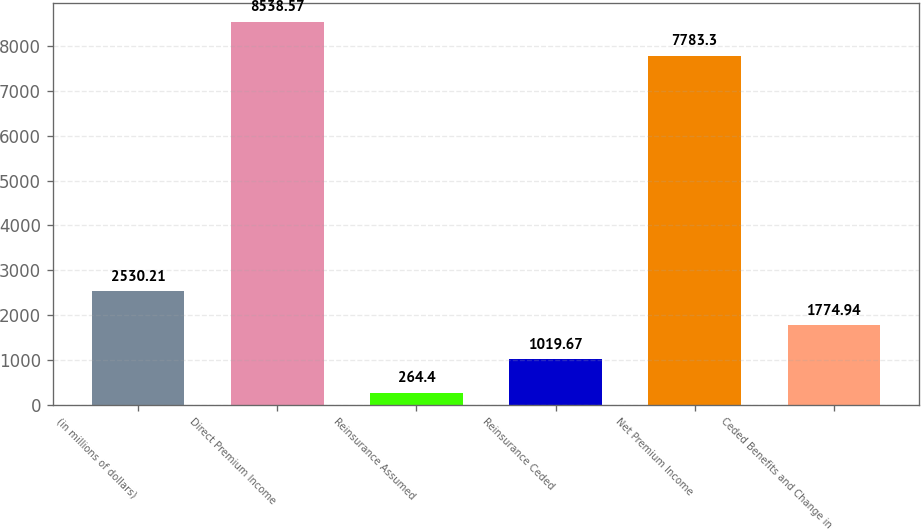<chart> <loc_0><loc_0><loc_500><loc_500><bar_chart><fcel>(in millions of dollars)<fcel>Direct Premium Income<fcel>Reinsurance Assumed<fcel>Reinsurance Ceded<fcel>Net Premium Income<fcel>Ceded Benefits and Change in<nl><fcel>2530.21<fcel>8538.57<fcel>264.4<fcel>1019.67<fcel>7783.3<fcel>1774.94<nl></chart> 